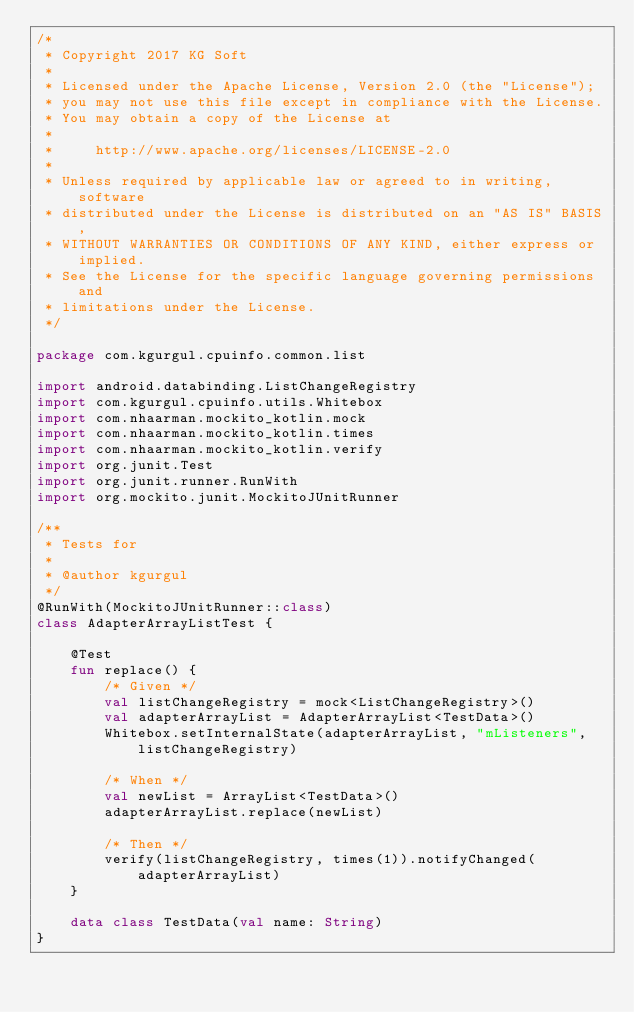Convert code to text. <code><loc_0><loc_0><loc_500><loc_500><_Kotlin_>/*
 * Copyright 2017 KG Soft
 *
 * Licensed under the Apache License, Version 2.0 (the "License");
 * you may not use this file except in compliance with the License.
 * You may obtain a copy of the License at
 *
 *     http://www.apache.org/licenses/LICENSE-2.0
 *
 * Unless required by applicable law or agreed to in writing, software
 * distributed under the License is distributed on an "AS IS" BASIS,
 * WITHOUT WARRANTIES OR CONDITIONS OF ANY KIND, either express or implied.
 * See the License for the specific language governing permissions and
 * limitations under the License.
 */

package com.kgurgul.cpuinfo.common.list

import android.databinding.ListChangeRegistry
import com.kgurgul.cpuinfo.utils.Whitebox
import com.nhaarman.mockito_kotlin.mock
import com.nhaarman.mockito_kotlin.times
import com.nhaarman.mockito_kotlin.verify
import org.junit.Test
import org.junit.runner.RunWith
import org.mockito.junit.MockitoJUnitRunner

/**
 * Tests for
 *
 * @author kgurgul
 */
@RunWith(MockitoJUnitRunner::class)
class AdapterArrayListTest {

    @Test
    fun replace() {
        /* Given */
        val listChangeRegistry = mock<ListChangeRegistry>()
        val adapterArrayList = AdapterArrayList<TestData>()
        Whitebox.setInternalState(adapterArrayList, "mListeners", listChangeRegistry)

        /* When */
        val newList = ArrayList<TestData>()
        adapterArrayList.replace(newList)

        /* Then */
        verify(listChangeRegistry, times(1)).notifyChanged(adapterArrayList)
    }

    data class TestData(val name: String)
}</code> 